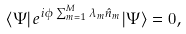Convert formula to latex. <formula><loc_0><loc_0><loc_500><loc_500>\langle \Psi | e ^ { i \phi \sum _ { m = 1 } ^ { M } \lambda _ { m } \hat { n } _ { m } } | \Psi \rangle = 0 ,</formula> 